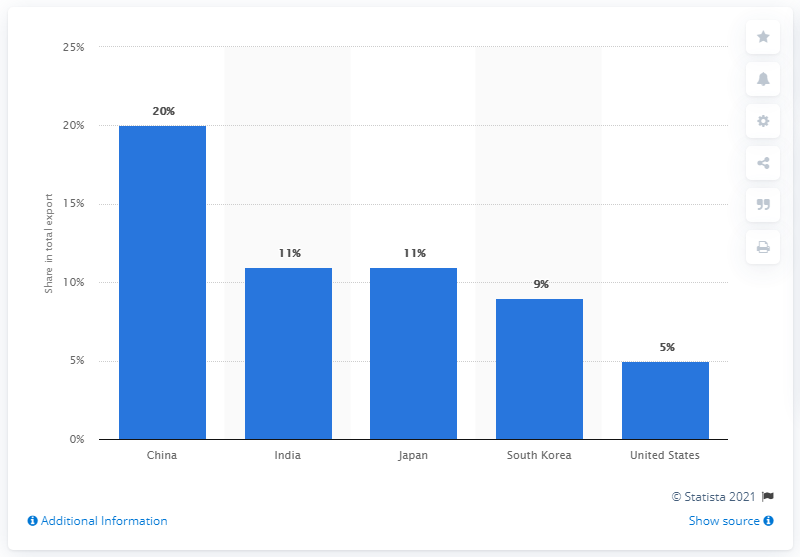Identify some key points in this picture. In 2019, approximately 11.6% of Saudi Arabia's total exports were sourced from China. The most important export partner of Saudi Arabia in 2019 was China. 